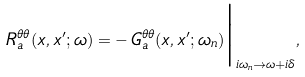<formula> <loc_0><loc_0><loc_500><loc_500>R ^ { \theta \theta } _ { a } ( x , x ^ { \prime } ; \omega ) = - \, G _ { a } ^ { \theta \theta } ( x , x ^ { \prime } ; \omega _ { n } ) \Big | _ { i \omega _ { n } \rightarrow \omega + i \delta } ,</formula> 